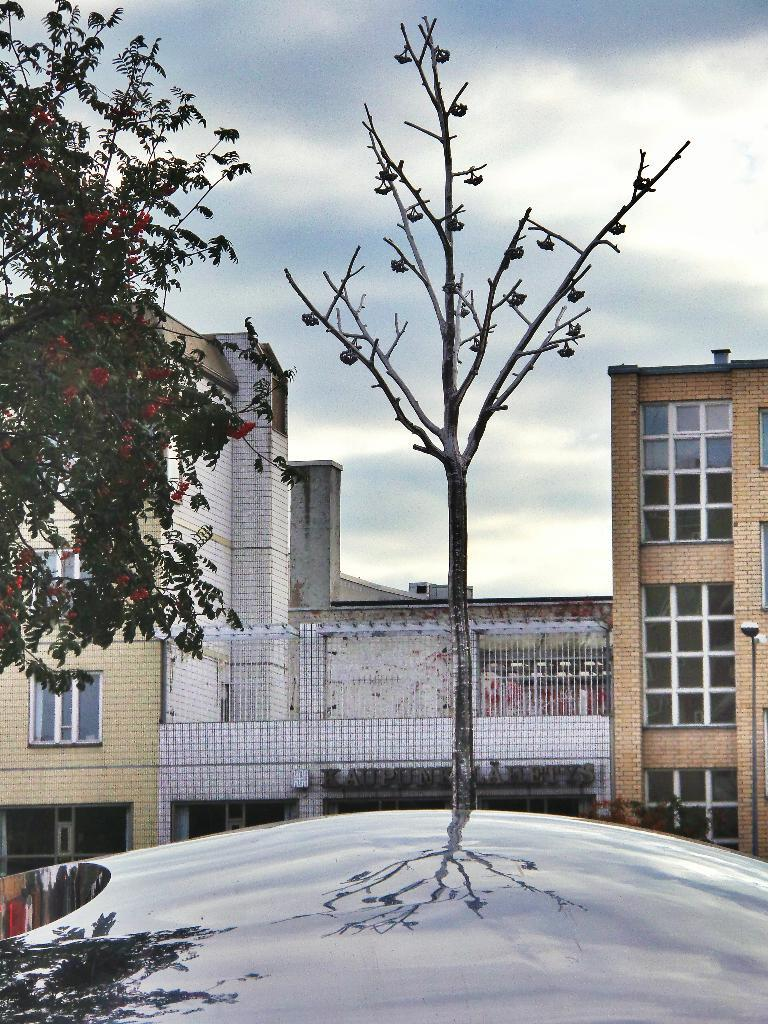What type of vegetation is visible in the image? There are trees in front of the image. What type of structures can be seen in the background of the image? There are buildings in the background of the image. What is visible in the sky in the image? The sky is visible in the background of the image. What is the reflection of at the bottom of the image? The reflection of the trees can be seen at the bottom of the image. Can you see a tooth in the reflection of the trees at the bottom of the image? There is no tooth present in the image; it features a reflection of trees. Is there an airplane flying over the buildings in the background of the image? There is no airplane visible in the image; it only shows trees, buildings, and the sky. 